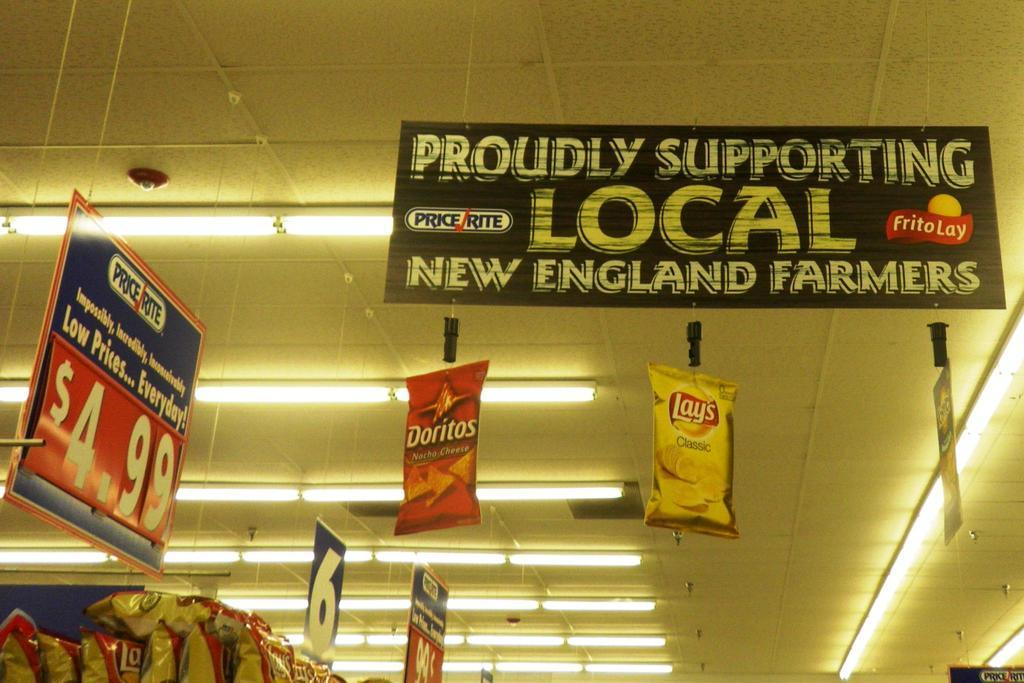What can be seen in large quantities in the image? There are many boards in the image. What is located at the top of the image? There are lights at the top in the image. Where are the food packets situated in the image? The food packets are on the left side of the image. Can you see any clouds in the image? There is no mention of clouds in the provided facts, and therefore we cannot determine if any are present in the image. How many people are pushing the boards in the image? There is no mention of people or pushing in the provided facts, and therefore we cannot determine if any are present in the image. 